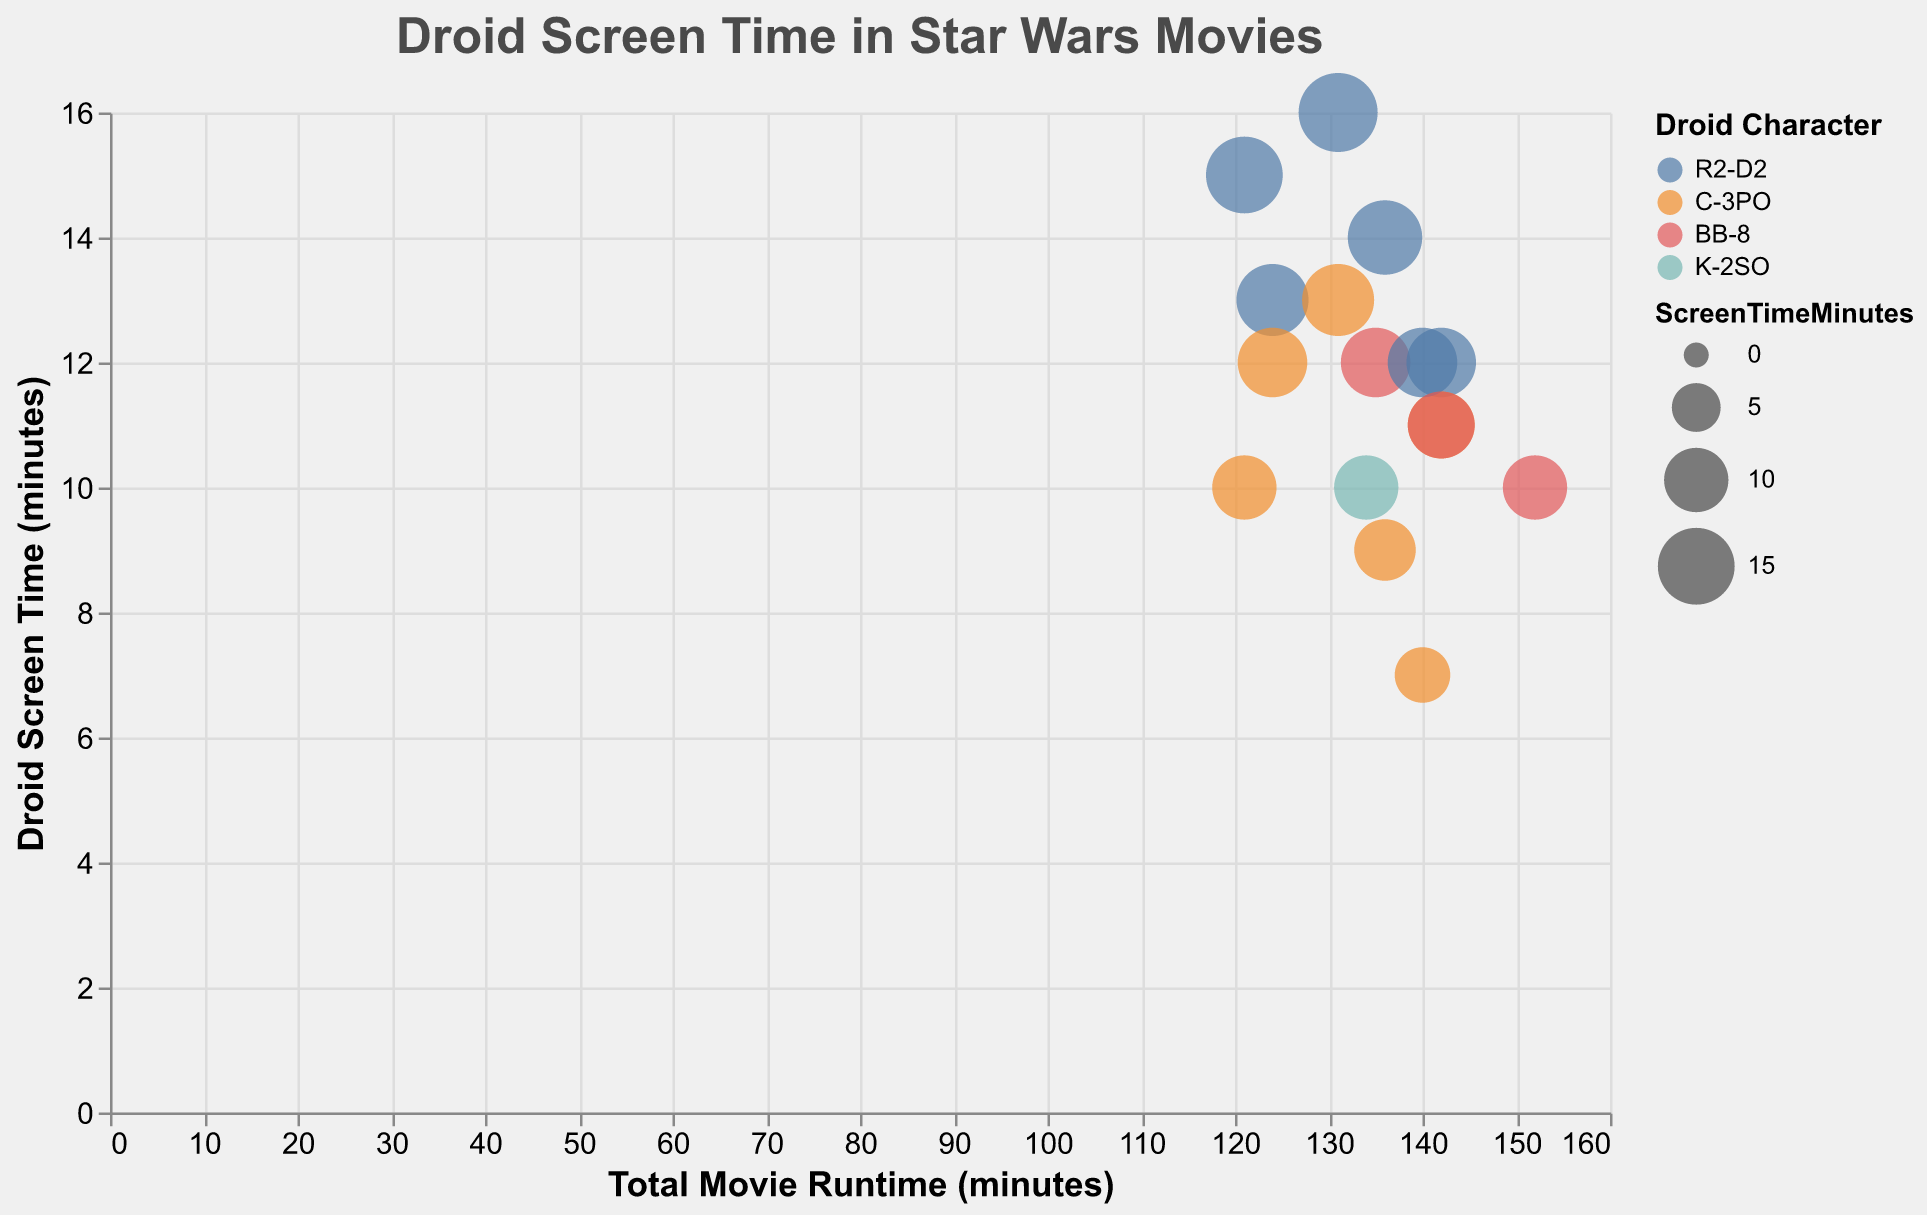How many droid characters are represented in the figure? To determine the number of droid characters, look at the color scheme legend on the right side of the figure. The legend shows four colors, each representing a different droid character: R2-D2, C-3PO, BB-8, and K-2SO.
Answer: Four Which droid character has the most screen time in "Star Wars: Episode VI - Return of the Jedi"? Identify the circles corresponding to "Star Wars: Episode VI - Return of the Jedi" and check their sizes. The larger the circle, the more screen time it represents. The largest circle for this movie is colored blue indicating R2-D2.
Answer: R2-D2 What is the total movie runtime of "Star Wars: Episode VIII - The Last Jedi"? Find the point(s) representing "Star Wars: Episode VIII - The Last Jedi" by looking at the tooltip information. The x-axis value for this movie is 152, which indicates the total movie runtime in minutes.
Answer: 152 minutes Who has more screen time in "Star Wars: Episode V - The Empire Strikes Back," R2-D2 or C-3PO? Locate the points for "Star Wars: Episode V - The Empire Strikes Back" and check the tooltip for screen time. Both droids have similar circle sizes, but R2-D2 has 13 minutes while C-3PO has 12 minutes.
Answer: R2-D2 What is the screen time to movie runtime ratio for BB-8 in "Star Wars: Episode VII - The Force Awakens"? Using the values for BB-8 in "Star Wars: Episode VII - The Force Awakens," the screen time is 12 minutes, and the total movie runtime is 135 minutes. The ratio is calculated as 12/135.
Answer: 0.089 Which movie has the highest total runtime? Check the x-axis values and identify the furthest bubble to the right, indicating the longest total movie runtime. "Star Wars: Episode VIII - The Last Jedi" has a total runtime of 152 minutes, which is the highest.
Answer: "Star Wars: Episode VIII - The Last Jedi" Does any movie feature both R2-D2 and BB-8? Cross-reference the characters and movies. There’s no single movie where both R2-D2 and BB-8 appear based on the data provided.
Answer: No Which movie features the longest screen time for any droid character? Check the tooltip of each bubble to find the highest screen time value. The movie with the highest screen time is "Star Wars: Episode VI - Return of the Jedi," featuring R2-D2 with 16 minutes.
Answer: "Star Wars: Episode VI - Return of the Jedi" What is the combined screen time for all droid characters in "Star Wars: Episode I - The Phantom Menace"? Identify the bubbles for "Star Wars: Episode I - The Phantom Menace" and add the screen time for each droid. R2-D2 has 14 minutes, and C-3PO has 9 minutes. The total is 14 + 9 = 23 minutes.
Answer: 23 minutes 